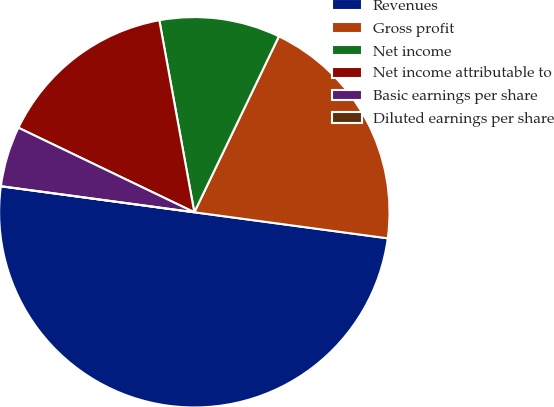Convert chart. <chart><loc_0><loc_0><loc_500><loc_500><pie_chart><fcel>Revenues<fcel>Gross profit<fcel>Net income<fcel>Net income attributable to<fcel>Basic earnings per share<fcel>Diluted earnings per share<nl><fcel>50.0%<fcel>20.0%<fcel>10.0%<fcel>15.0%<fcel>5.0%<fcel>0.0%<nl></chart> 